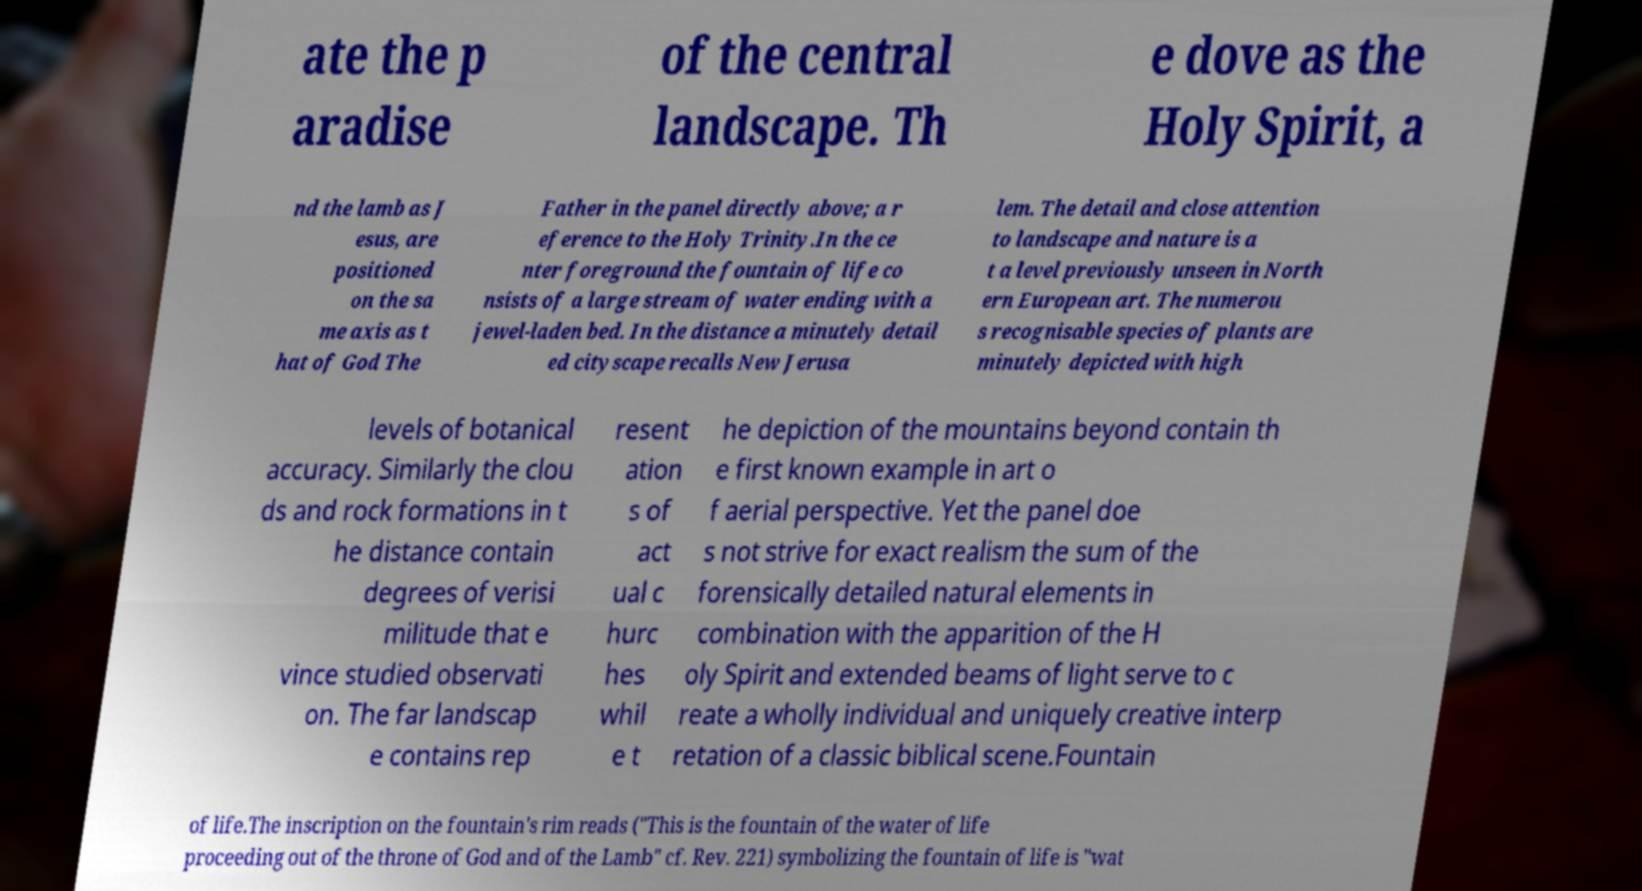For documentation purposes, I need the text within this image transcribed. Could you provide that? ate the p aradise of the central landscape. Th e dove as the Holy Spirit, a nd the lamb as J esus, are positioned on the sa me axis as t hat of God The Father in the panel directly above; a r eference to the Holy Trinity.In the ce nter foreground the fountain of life co nsists of a large stream of water ending with a jewel-laden bed. In the distance a minutely detail ed cityscape recalls New Jerusa lem. The detail and close attention to landscape and nature is a t a level previously unseen in North ern European art. The numerou s recognisable species of plants are minutely depicted with high levels of botanical accuracy. Similarly the clou ds and rock formations in t he distance contain degrees of verisi militude that e vince studied observati on. The far landscap e contains rep resent ation s of act ual c hurc hes whil e t he depiction of the mountains beyond contain th e first known example in art o f aerial perspective. Yet the panel doe s not strive for exact realism the sum of the forensically detailed natural elements in combination with the apparition of the H oly Spirit and extended beams of light serve to c reate a wholly individual and uniquely creative interp retation of a classic biblical scene.Fountain of life.The inscription on the fountain's rim reads ("This is the fountain of the water of life proceeding out of the throne of God and of the Lamb" cf. Rev. 221) symbolizing the fountain of life is "wat 